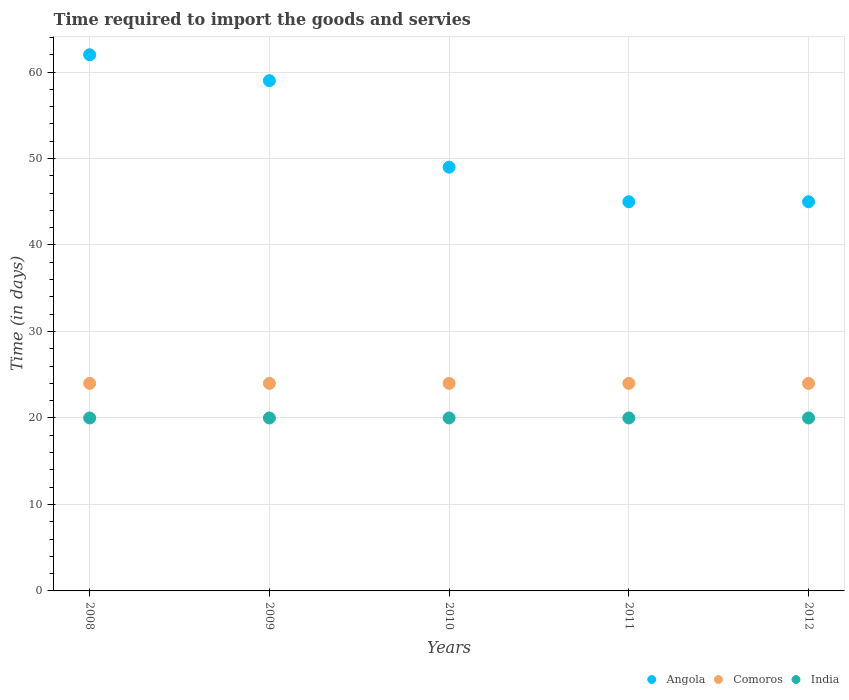How many different coloured dotlines are there?
Offer a very short reply. 3. Is the number of dotlines equal to the number of legend labels?
Ensure brevity in your answer.  Yes. What is the number of days required to import the goods and services in India in 2010?
Make the answer very short. 20. Across all years, what is the minimum number of days required to import the goods and services in Comoros?
Provide a short and direct response. 24. In which year was the number of days required to import the goods and services in Angola maximum?
Provide a succinct answer. 2008. In which year was the number of days required to import the goods and services in India minimum?
Give a very brief answer. 2008. What is the difference between the number of days required to import the goods and services in Angola in 2008 and that in 2010?
Provide a succinct answer. 13. What is the difference between the number of days required to import the goods and services in India in 2012 and the number of days required to import the goods and services in Comoros in 2009?
Offer a terse response. -4. What is the average number of days required to import the goods and services in Angola per year?
Provide a succinct answer. 52. In how many years, is the number of days required to import the goods and services in Angola greater than 62 days?
Keep it short and to the point. 0. Is the number of days required to import the goods and services in Comoros in 2010 less than that in 2012?
Make the answer very short. No. Is the difference between the number of days required to import the goods and services in India in 2009 and 2010 greater than the difference between the number of days required to import the goods and services in Angola in 2009 and 2010?
Provide a succinct answer. No. What is the difference between the highest and the second highest number of days required to import the goods and services in Comoros?
Make the answer very short. 0. What is the difference between the highest and the lowest number of days required to import the goods and services in India?
Make the answer very short. 0. In how many years, is the number of days required to import the goods and services in Comoros greater than the average number of days required to import the goods and services in Comoros taken over all years?
Ensure brevity in your answer.  0. Is it the case that in every year, the sum of the number of days required to import the goods and services in India and number of days required to import the goods and services in Angola  is greater than the number of days required to import the goods and services in Comoros?
Give a very brief answer. Yes. Is the number of days required to import the goods and services in India strictly greater than the number of days required to import the goods and services in Angola over the years?
Your answer should be very brief. No. Is the number of days required to import the goods and services in Angola strictly less than the number of days required to import the goods and services in Comoros over the years?
Keep it short and to the point. No. How many years are there in the graph?
Your response must be concise. 5. Are the values on the major ticks of Y-axis written in scientific E-notation?
Offer a very short reply. No. How many legend labels are there?
Ensure brevity in your answer.  3. What is the title of the graph?
Offer a very short reply. Time required to import the goods and servies. What is the label or title of the X-axis?
Your response must be concise. Years. What is the label or title of the Y-axis?
Give a very brief answer. Time (in days). What is the Time (in days) of Angola in 2009?
Offer a very short reply. 59. What is the Time (in days) of Comoros in 2009?
Ensure brevity in your answer.  24. What is the Time (in days) of Comoros in 2010?
Your response must be concise. 24. What is the Time (in days) in Angola in 2011?
Your answer should be compact. 45. What is the Time (in days) of India in 2011?
Provide a succinct answer. 20. What is the Time (in days) in Comoros in 2012?
Give a very brief answer. 24. What is the Time (in days) of India in 2012?
Give a very brief answer. 20. Across all years, what is the maximum Time (in days) in Angola?
Ensure brevity in your answer.  62. Across all years, what is the maximum Time (in days) of Comoros?
Make the answer very short. 24. Across all years, what is the minimum Time (in days) in Angola?
Your response must be concise. 45. Across all years, what is the minimum Time (in days) in Comoros?
Make the answer very short. 24. What is the total Time (in days) in Angola in the graph?
Provide a succinct answer. 260. What is the total Time (in days) in Comoros in the graph?
Your response must be concise. 120. What is the difference between the Time (in days) of Angola in 2008 and that in 2009?
Provide a succinct answer. 3. What is the difference between the Time (in days) of Comoros in 2008 and that in 2009?
Keep it short and to the point. 0. What is the difference between the Time (in days) in India in 2008 and that in 2009?
Your answer should be compact. 0. What is the difference between the Time (in days) in Comoros in 2008 and that in 2010?
Provide a succinct answer. 0. What is the difference between the Time (in days) of Angola in 2008 and that in 2011?
Offer a terse response. 17. What is the difference between the Time (in days) in Comoros in 2008 and that in 2011?
Provide a short and direct response. 0. What is the difference between the Time (in days) of India in 2008 and that in 2011?
Provide a succinct answer. 0. What is the difference between the Time (in days) of Angola in 2008 and that in 2012?
Provide a short and direct response. 17. What is the difference between the Time (in days) of Comoros in 2008 and that in 2012?
Provide a short and direct response. 0. What is the difference between the Time (in days) of India in 2008 and that in 2012?
Offer a very short reply. 0. What is the difference between the Time (in days) in Comoros in 2009 and that in 2010?
Give a very brief answer. 0. What is the difference between the Time (in days) of India in 2009 and that in 2010?
Your answer should be very brief. 0. What is the difference between the Time (in days) in Angola in 2009 and that in 2011?
Provide a succinct answer. 14. What is the difference between the Time (in days) in India in 2009 and that in 2011?
Provide a short and direct response. 0. What is the difference between the Time (in days) of Comoros in 2009 and that in 2012?
Your response must be concise. 0. What is the difference between the Time (in days) of Angola in 2010 and that in 2011?
Your response must be concise. 4. What is the difference between the Time (in days) in Comoros in 2010 and that in 2011?
Offer a terse response. 0. What is the difference between the Time (in days) of India in 2010 and that in 2012?
Your response must be concise. 0. What is the difference between the Time (in days) in India in 2011 and that in 2012?
Offer a terse response. 0. What is the difference between the Time (in days) in Angola in 2008 and the Time (in days) in Comoros in 2009?
Keep it short and to the point. 38. What is the difference between the Time (in days) in Angola in 2008 and the Time (in days) in India in 2009?
Give a very brief answer. 42. What is the difference between the Time (in days) of Comoros in 2008 and the Time (in days) of India in 2009?
Your answer should be compact. 4. What is the difference between the Time (in days) of Angola in 2008 and the Time (in days) of Comoros in 2010?
Provide a short and direct response. 38. What is the difference between the Time (in days) of Comoros in 2008 and the Time (in days) of India in 2010?
Keep it short and to the point. 4. What is the difference between the Time (in days) in Comoros in 2008 and the Time (in days) in India in 2011?
Make the answer very short. 4. What is the difference between the Time (in days) in Comoros in 2009 and the Time (in days) in India in 2010?
Ensure brevity in your answer.  4. What is the difference between the Time (in days) in Angola in 2009 and the Time (in days) in Comoros in 2011?
Keep it short and to the point. 35. What is the difference between the Time (in days) in Angola in 2009 and the Time (in days) in India in 2011?
Your response must be concise. 39. What is the difference between the Time (in days) of Angola in 2009 and the Time (in days) of India in 2012?
Make the answer very short. 39. What is the difference between the Time (in days) in Comoros in 2009 and the Time (in days) in India in 2012?
Keep it short and to the point. 4. What is the difference between the Time (in days) in Angola in 2010 and the Time (in days) in Comoros in 2011?
Offer a very short reply. 25. What is the difference between the Time (in days) in Angola in 2010 and the Time (in days) in India in 2011?
Your answer should be compact. 29. What is the difference between the Time (in days) of Angola in 2010 and the Time (in days) of India in 2012?
Make the answer very short. 29. What is the difference between the Time (in days) of Angola in 2011 and the Time (in days) of India in 2012?
Offer a terse response. 25. What is the difference between the Time (in days) of Comoros in 2011 and the Time (in days) of India in 2012?
Provide a succinct answer. 4. What is the average Time (in days) in Comoros per year?
Your answer should be compact. 24. What is the average Time (in days) of India per year?
Your answer should be compact. 20. In the year 2008, what is the difference between the Time (in days) in Angola and Time (in days) in Comoros?
Give a very brief answer. 38. In the year 2008, what is the difference between the Time (in days) of Angola and Time (in days) of India?
Make the answer very short. 42. In the year 2009, what is the difference between the Time (in days) of Comoros and Time (in days) of India?
Your answer should be compact. 4. In the year 2010, what is the difference between the Time (in days) in Angola and Time (in days) in India?
Offer a very short reply. 29. In the year 2011, what is the difference between the Time (in days) of Comoros and Time (in days) of India?
Your answer should be compact. 4. In the year 2012, what is the difference between the Time (in days) of Angola and Time (in days) of Comoros?
Provide a succinct answer. 21. In the year 2012, what is the difference between the Time (in days) in Comoros and Time (in days) in India?
Offer a very short reply. 4. What is the ratio of the Time (in days) of Angola in 2008 to that in 2009?
Offer a very short reply. 1.05. What is the ratio of the Time (in days) in Angola in 2008 to that in 2010?
Your response must be concise. 1.27. What is the ratio of the Time (in days) of India in 2008 to that in 2010?
Your answer should be very brief. 1. What is the ratio of the Time (in days) in Angola in 2008 to that in 2011?
Ensure brevity in your answer.  1.38. What is the ratio of the Time (in days) in India in 2008 to that in 2011?
Your answer should be very brief. 1. What is the ratio of the Time (in days) in Angola in 2008 to that in 2012?
Offer a very short reply. 1.38. What is the ratio of the Time (in days) of Comoros in 2008 to that in 2012?
Offer a terse response. 1. What is the ratio of the Time (in days) in India in 2008 to that in 2012?
Ensure brevity in your answer.  1. What is the ratio of the Time (in days) of Angola in 2009 to that in 2010?
Your response must be concise. 1.2. What is the ratio of the Time (in days) in Comoros in 2009 to that in 2010?
Give a very brief answer. 1. What is the ratio of the Time (in days) in India in 2009 to that in 2010?
Give a very brief answer. 1. What is the ratio of the Time (in days) in Angola in 2009 to that in 2011?
Offer a very short reply. 1.31. What is the ratio of the Time (in days) of Comoros in 2009 to that in 2011?
Make the answer very short. 1. What is the ratio of the Time (in days) in India in 2009 to that in 2011?
Provide a short and direct response. 1. What is the ratio of the Time (in days) of Angola in 2009 to that in 2012?
Give a very brief answer. 1.31. What is the ratio of the Time (in days) of Comoros in 2009 to that in 2012?
Your answer should be compact. 1. What is the ratio of the Time (in days) of Angola in 2010 to that in 2011?
Keep it short and to the point. 1.09. What is the ratio of the Time (in days) in Comoros in 2010 to that in 2011?
Ensure brevity in your answer.  1. What is the ratio of the Time (in days) of Angola in 2010 to that in 2012?
Provide a short and direct response. 1.09. What is the ratio of the Time (in days) in Comoros in 2010 to that in 2012?
Make the answer very short. 1. What is the ratio of the Time (in days) of India in 2010 to that in 2012?
Your answer should be compact. 1. What is the ratio of the Time (in days) in Angola in 2011 to that in 2012?
Keep it short and to the point. 1. What is the ratio of the Time (in days) in India in 2011 to that in 2012?
Keep it short and to the point. 1. What is the difference between the highest and the second highest Time (in days) of Comoros?
Your answer should be compact. 0. What is the difference between the highest and the second highest Time (in days) in India?
Your answer should be compact. 0. What is the difference between the highest and the lowest Time (in days) of Comoros?
Your answer should be compact. 0. What is the difference between the highest and the lowest Time (in days) in India?
Make the answer very short. 0. 